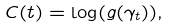Convert formula to latex. <formula><loc_0><loc_0><loc_500><loc_500>C ( t ) = \log ( g ( \gamma _ { t } ) ) ,</formula> 